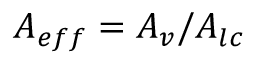<formula> <loc_0><loc_0><loc_500><loc_500>A _ { e f f } = A _ { v } / A _ { l c }</formula> 